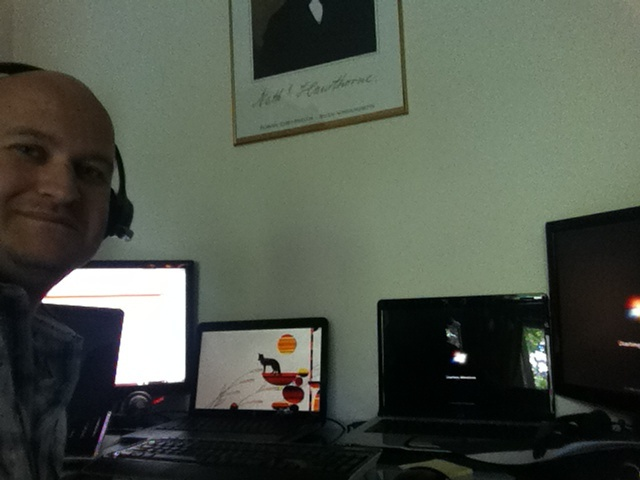Describe the objects in this image and their specific colors. I can see people in gray, black, and maroon tones, laptop in gray, black, white, and darkgray tones, tv in gray, black, white, and darkgray tones, tv in gray, black, maroon, and ivory tones, and laptop in gray, black, and darkgray tones in this image. 